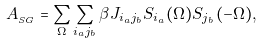<formula> <loc_0><loc_0><loc_500><loc_500>A _ { _ { S G } } = \sum _ { \Omega } \sum _ { i _ { a } j _ { b } } \beta J _ { i _ { a } j _ { b } } S _ { i _ { a } } ( \Omega ) S _ { j _ { b } } ( - \Omega ) ,</formula> 